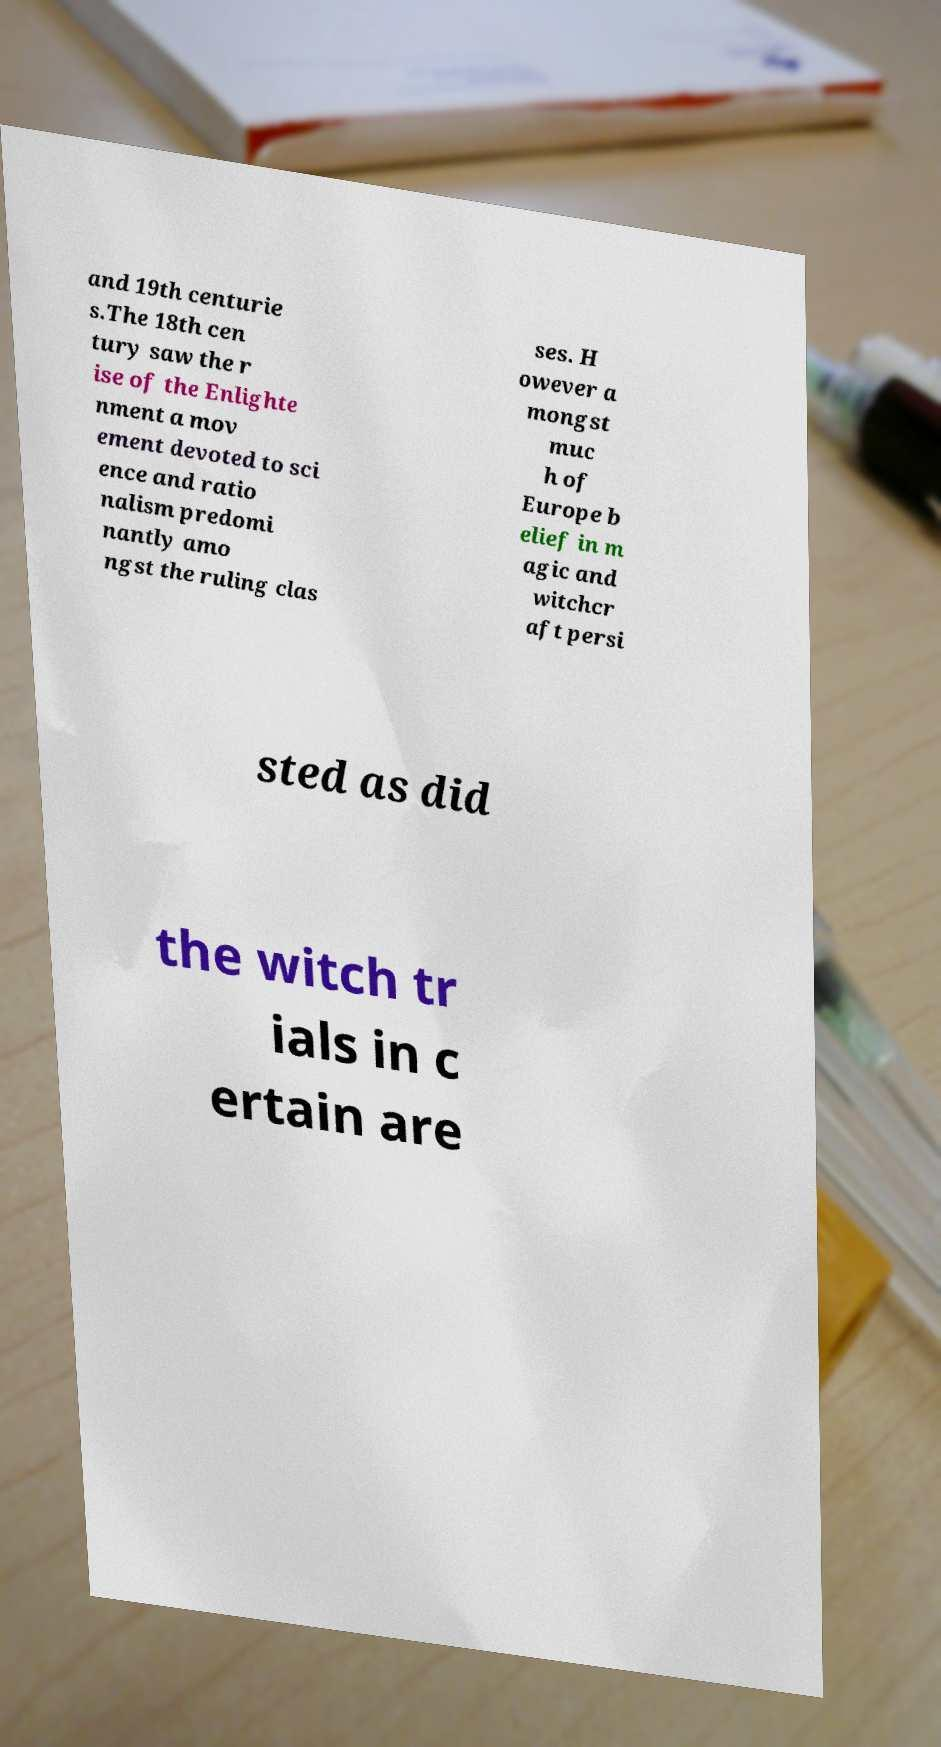I need the written content from this picture converted into text. Can you do that? and 19th centurie s.The 18th cen tury saw the r ise of the Enlighte nment a mov ement devoted to sci ence and ratio nalism predomi nantly amo ngst the ruling clas ses. H owever a mongst muc h of Europe b elief in m agic and witchcr aft persi sted as did the witch tr ials in c ertain are 